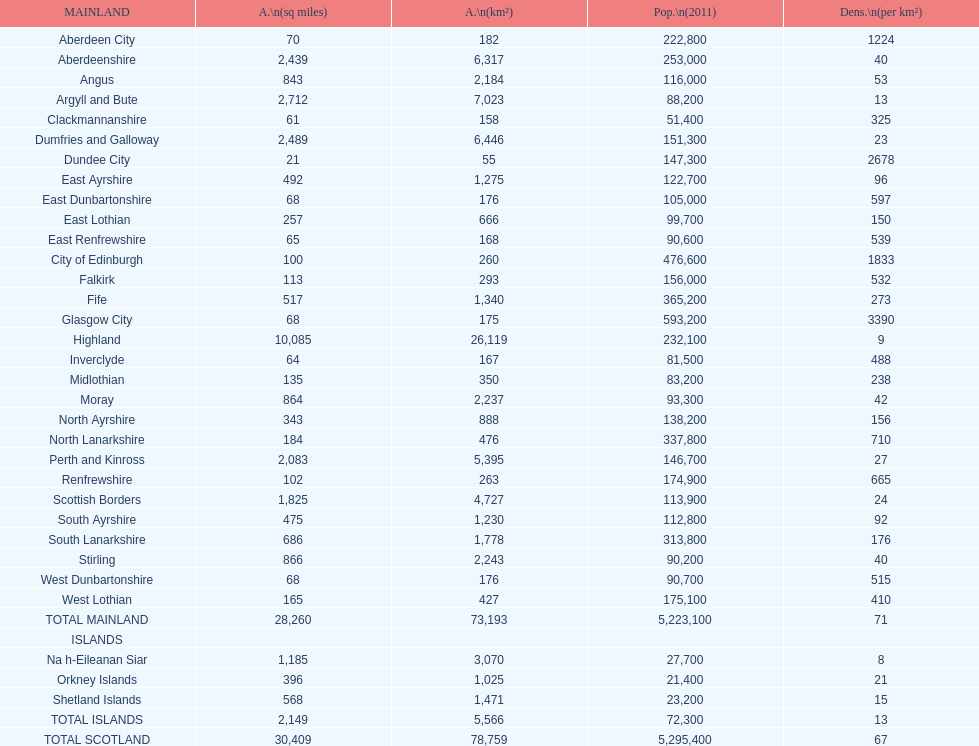Which specific subdivision surpasses argyll and bute in terms of area? Highland. 